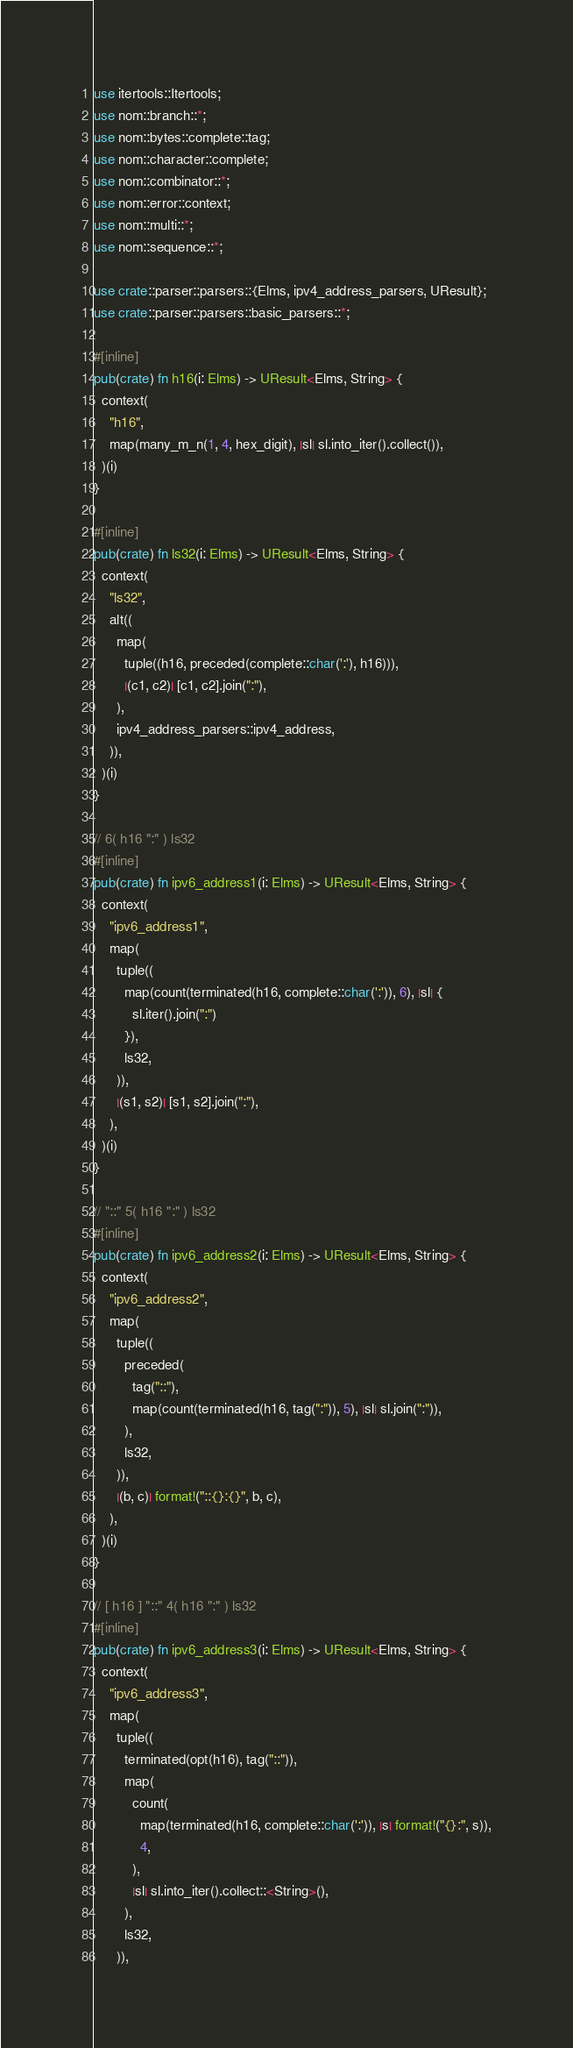<code> <loc_0><loc_0><loc_500><loc_500><_Rust_>use itertools::Itertools;
use nom::branch::*;
use nom::bytes::complete::tag;
use nom::character::complete;
use nom::combinator::*;
use nom::error::context;
use nom::multi::*;
use nom::sequence::*;

use crate::parser::parsers::{Elms, ipv4_address_parsers, UResult};
use crate::parser::parsers::basic_parsers::*;

#[inline]
pub(crate) fn h16(i: Elms) -> UResult<Elms, String> {
  context(
    "h16",
    map(many_m_n(1, 4, hex_digit), |sl| sl.into_iter().collect()),
  )(i)
}

#[inline]
pub(crate) fn ls32(i: Elms) -> UResult<Elms, String> {
  context(
    "ls32",
    alt((
      map(
        tuple((h16, preceded(complete::char(':'), h16))),
        |(c1, c2)| [c1, c2].join(":"),
      ),
      ipv4_address_parsers::ipv4_address,
    )),
  )(i)
}

// 6( h16 ":" ) ls32
#[inline]
pub(crate) fn ipv6_address1(i: Elms) -> UResult<Elms, String> {
  context(
    "ipv6_address1",
    map(
      tuple((
        map(count(terminated(h16, complete::char(':')), 6), |sl| {
          sl.iter().join(":")
        }),
        ls32,
      )),
      |(s1, s2)| [s1, s2].join(":"),
    ),
  )(i)
}

// "::" 5( h16 ":" ) ls32
#[inline]
pub(crate) fn ipv6_address2(i: Elms) -> UResult<Elms, String> {
  context(
    "ipv6_address2",
    map(
      tuple((
        preceded(
          tag("::"),
          map(count(terminated(h16, tag(":")), 5), |sl| sl.join(":")),
        ),
        ls32,
      )),
      |(b, c)| format!("::{}:{}", b, c),
    ),
  )(i)
}

// [ h16 ] "::" 4( h16 ":" ) ls32
#[inline]
pub(crate) fn ipv6_address3(i: Elms) -> UResult<Elms, String> {
  context(
    "ipv6_address3",
    map(
      tuple((
        terminated(opt(h16), tag("::")),
        map(
          count(
            map(terminated(h16, complete::char(':')), |s| format!("{}:", s)),
            4,
          ),
          |sl| sl.into_iter().collect::<String>(),
        ),
        ls32,
      )),</code> 